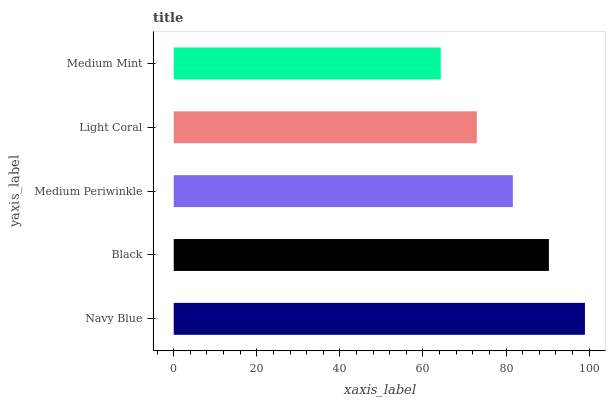Is Medium Mint the minimum?
Answer yes or no. Yes. Is Navy Blue the maximum?
Answer yes or no. Yes. Is Black the minimum?
Answer yes or no. No. Is Black the maximum?
Answer yes or no. No. Is Navy Blue greater than Black?
Answer yes or no. Yes. Is Black less than Navy Blue?
Answer yes or no. Yes. Is Black greater than Navy Blue?
Answer yes or no. No. Is Navy Blue less than Black?
Answer yes or no. No. Is Medium Periwinkle the high median?
Answer yes or no. Yes. Is Medium Periwinkle the low median?
Answer yes or no. Yes. Is Navy Blue the high median?
Answer yes or no. No. Is Navy Blue the low median?
Answer yes or no. No. 